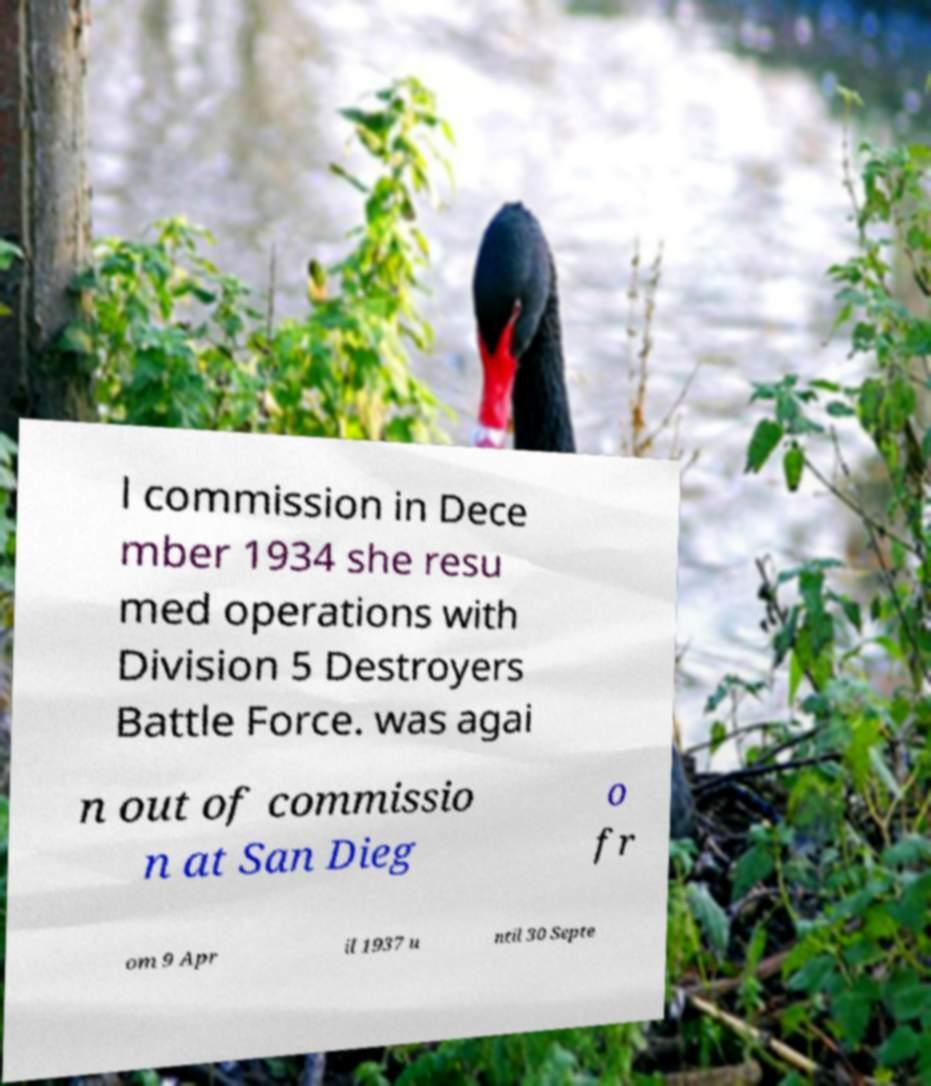Please read and relay the text visible in this image. What does it say? l commission in Dece mber 1934 she resu med operations with Division 5 Destroyers Battle Force. was agai n out of commissio n at San Dieg o fr om 9 Apr il 1937 u ntil 30 Septe 